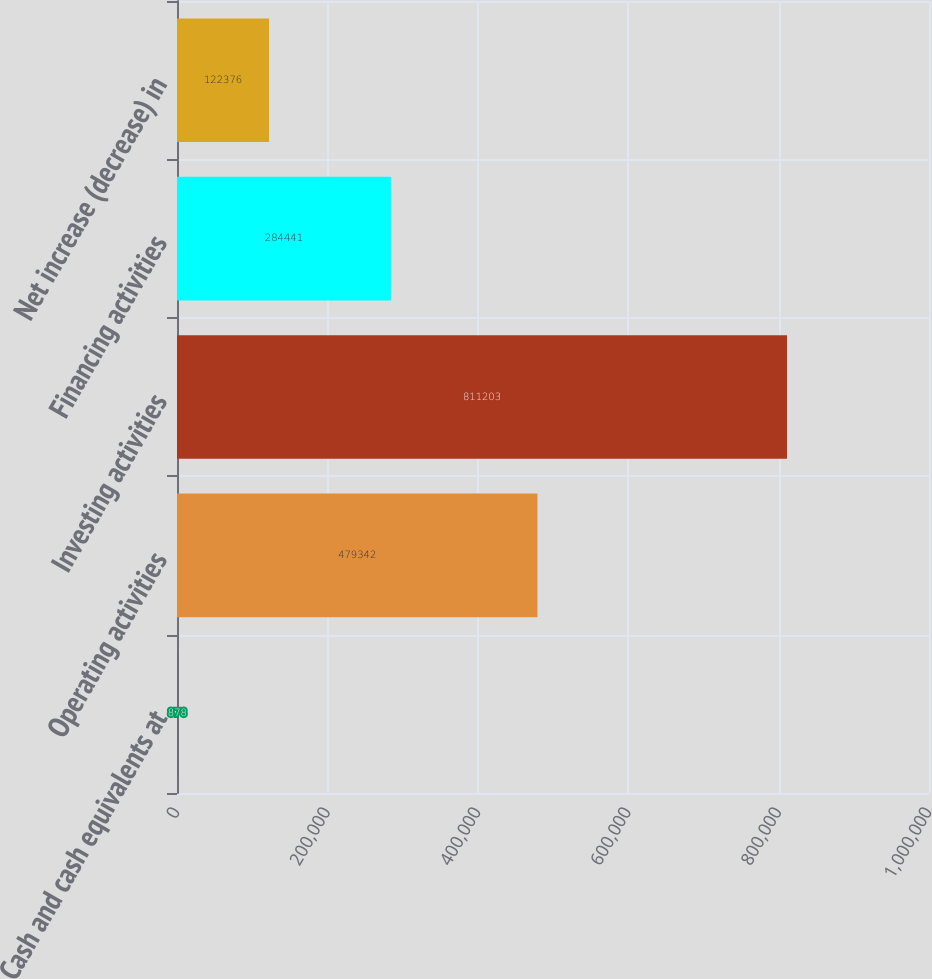<chart> <loc_0><loc_0><loc_500><loc_500><bar_chart><fcel>Cash and cash equivalents at<fcel>Operating activities<fcel>Investing activities<fcel>Financing activities<fcel>Net increase (decrease) in<nl><fcel>878<fcel>479342<fcel>811203<fcel>284441<fcel>122376<nl></chart> 